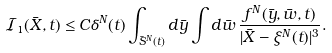Convert formula to latex. <formula><loc_0><loc_0><loc_500><loc_500>\mathcal { I } _ { 1 } ( \bar { X } , t ) \leq & \, C \delta ^ { N } ( t ) \int _ { \bar { S } ^ { N } ( t ) } d \bar { y } \int d \bar { w } \, \frac { f ^ { N } ( \bar { y } , \bar { w } , t ) } { | \bar { X } - \xi ^ { N } ( t ) | ^ { 3 } } .</formula> 